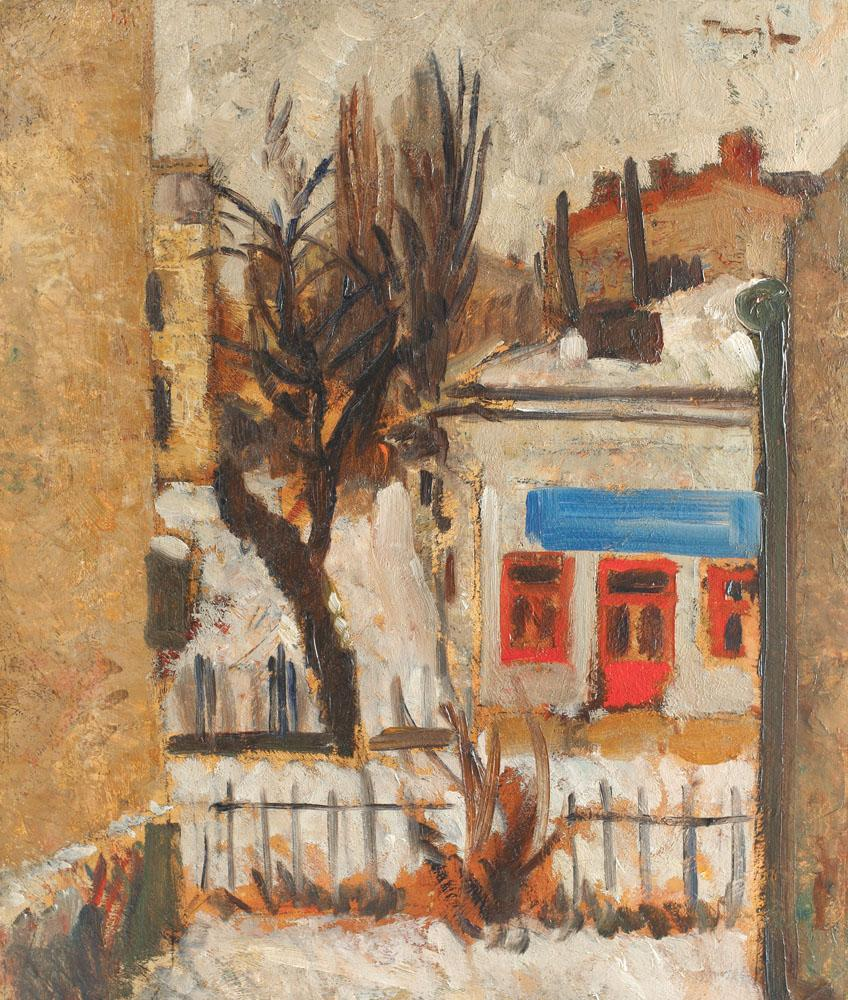What artistic techniques has the painter used to create texture in the scene? The painter has cleverly employed a combination of thick impasto and more fluid brushwork to imbue the scene with rich texture. The thick application of paint, particularly noticeable on the tree's bark and the facade of the buildings, creates a three-dimensional effect that invites the viewer to experience the tactility of the elements. Short, dynamic brushstrokes convey the roughness of surfaces and the fluidity of light and shadow. This contrast between the impasto and the smoother areas of the painting amplifies the depth and realism of this picturesque urban slice. 